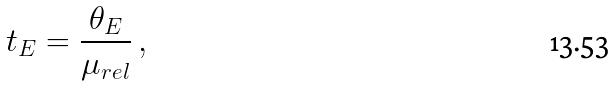Convert formula to latex. <formula><loc_0><loc_0><loc_500><loc_500>t _ { E } = \frac { \theta _ { E } } { \mu _ { r e l } } \, ,</formula> 